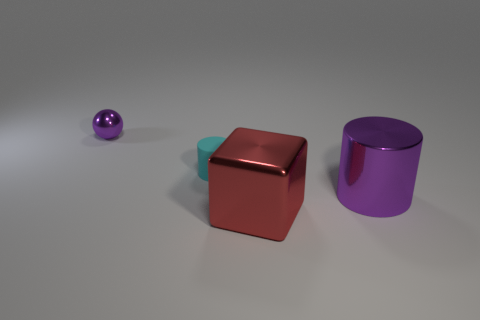What number of other things are the same size as the shiny block?
Offer a very short reply. 1. Is there a purple metallic sphere that is behind the purple shiny thing that is behind the cylinder on the left side of the big red shiny object?
Your answer should be compact. No. What is the size of the rubber object?
Give a very brief answer. Small. What size is the purple thing that is right of the big block?
Provide a short and direct response. Large. There is a thing in front of the metallic cylinder; is it the same size as the matte thing?
Your answer should be compact. No. Are there any other things that have the same color as the small shiny object?
Provide a succinct answer. Yes. What is the shape of the red shiny thing?
Your answer should be compact. Cube. How many things are right of the cyan object and behind the red metal thing?
Provide a succinct answer. 1. Is the small cylinder the same color as the small metal sphere?
Offer a terse response. No. There is a purple object that is the same shape as the cyan matte thing; what is it made of?
Provide a short and direct response. Metal. 